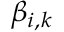Convert formula to latex. <formula><loc_0><loc_0><loc_500><loc_500>\beta _ { i , k }</formula> 